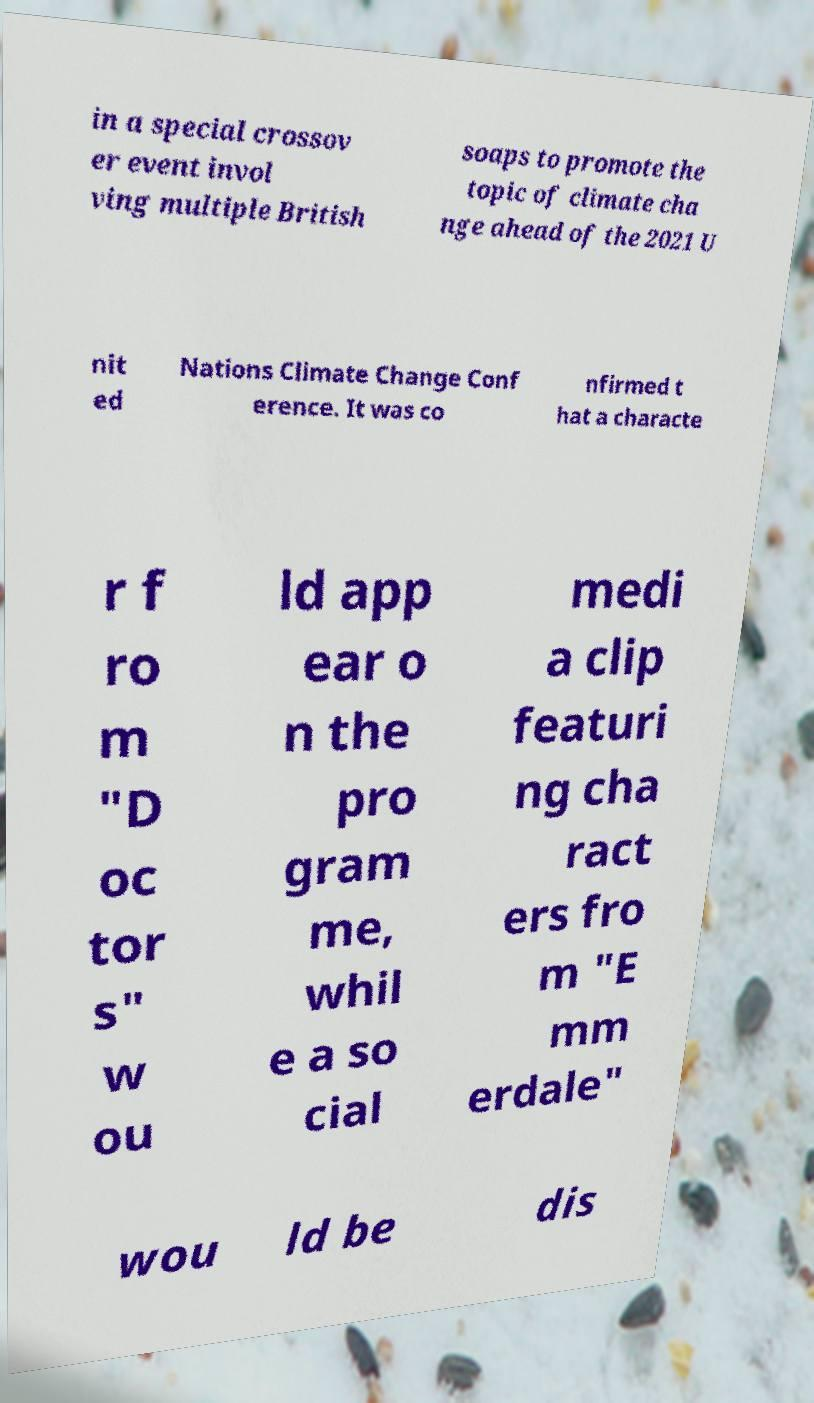There's text embedded in this image that I need extracted. Can you transcribe it verbatim? in a special crossov er event invol ving multiple British soaps to promote the topic of climate cha nge ahead of the 2021 U nit ed Nations Climate Change Conf erence. It was co nfirmed t hat a characte r f ro m "D oc tor s" w ou ld app ear o n the pro gram me, whil e a so cial medi a clip featuri ng cha ract ers fro m "E mm erdale" wou ld be dis 